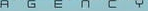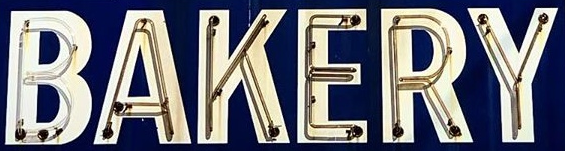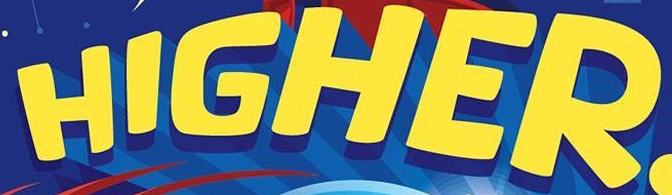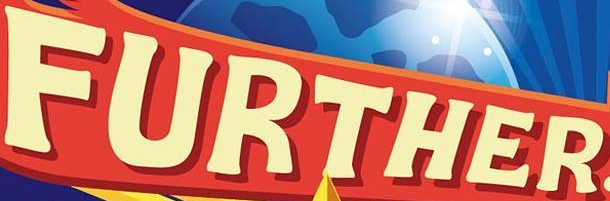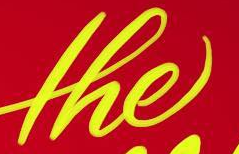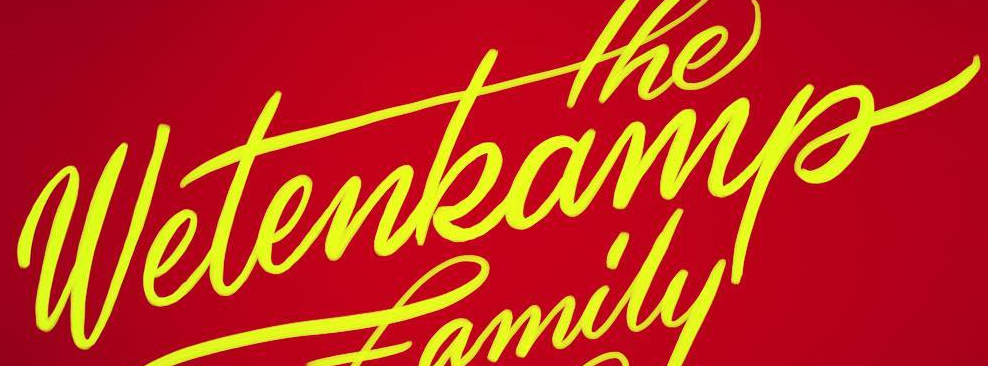Read the text from these images in sequence, separated by a semicolon. AGENCY; BAKERY; HIGHER; FURTHER; the; wetenkamp 